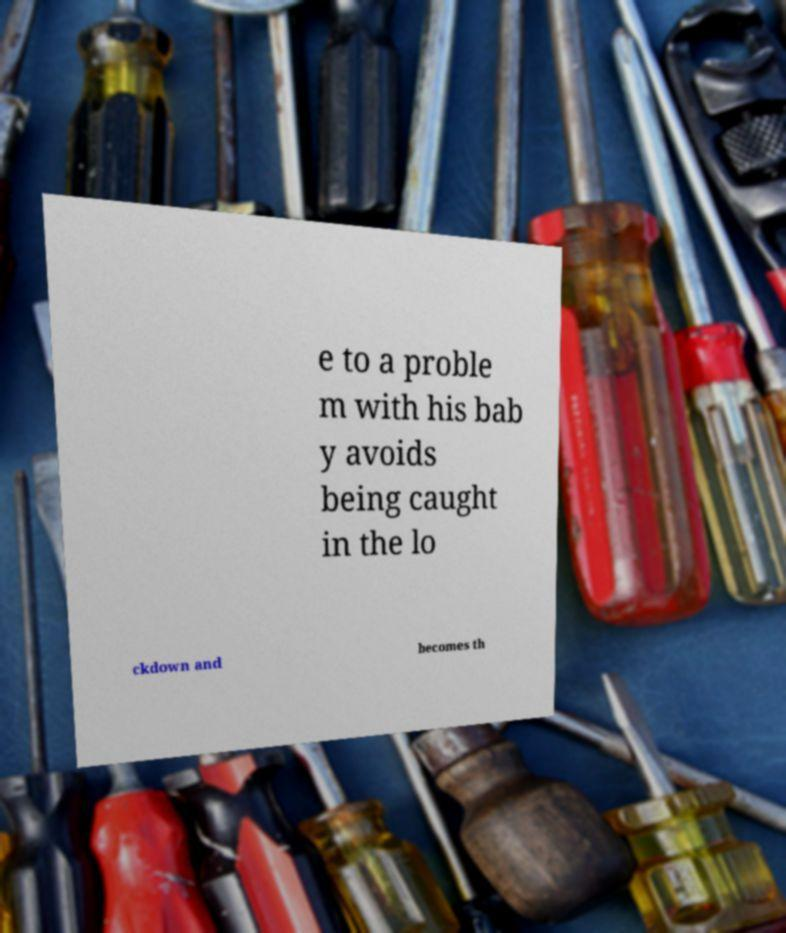For documentation purposes, I need the text within this image transcribed. Could you provide that? e to a proble m with his bab y avoids being caught in the lo ckdown and becomes th 